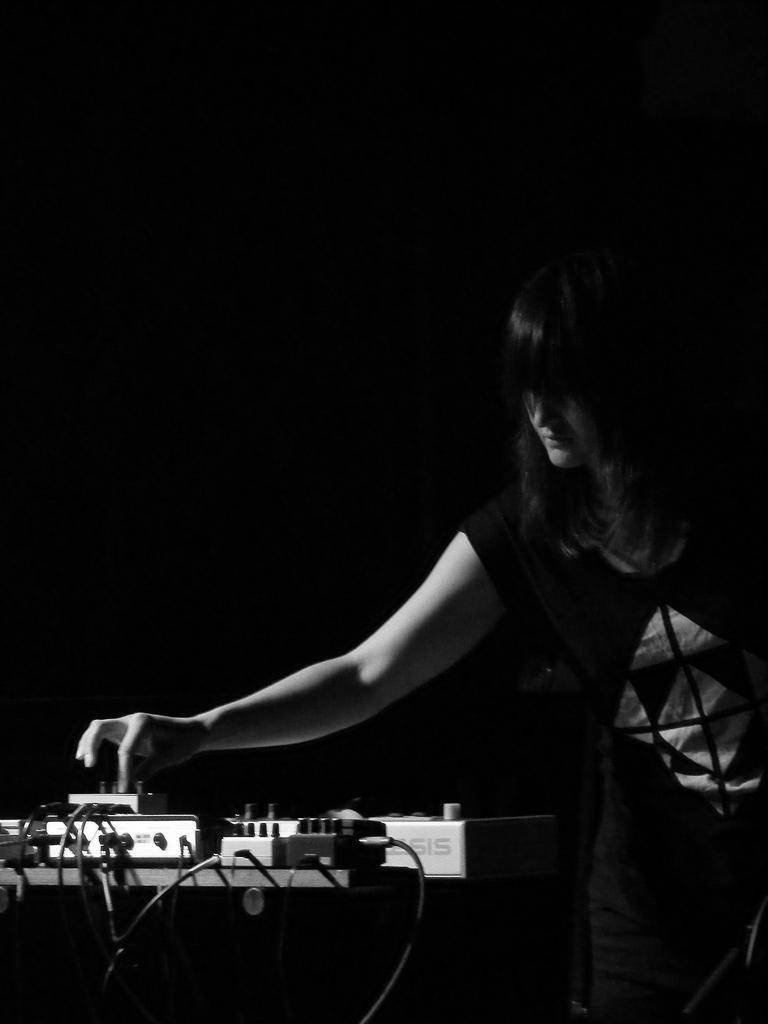Who is present in the image? There is a woman in the image. What is the woman wearing? The woman is wearing a black dress. What can be seen on the table in the image? There are switch boards on the table. Can you describe the lighting in the image? The image is slightly dark. What type of star can be seen in the woman's hand in the image? There is no star present in the image, and the woman's hands are not visible. What month is depicted in the image? The image does not depict a specific month; it is a still photograph. 